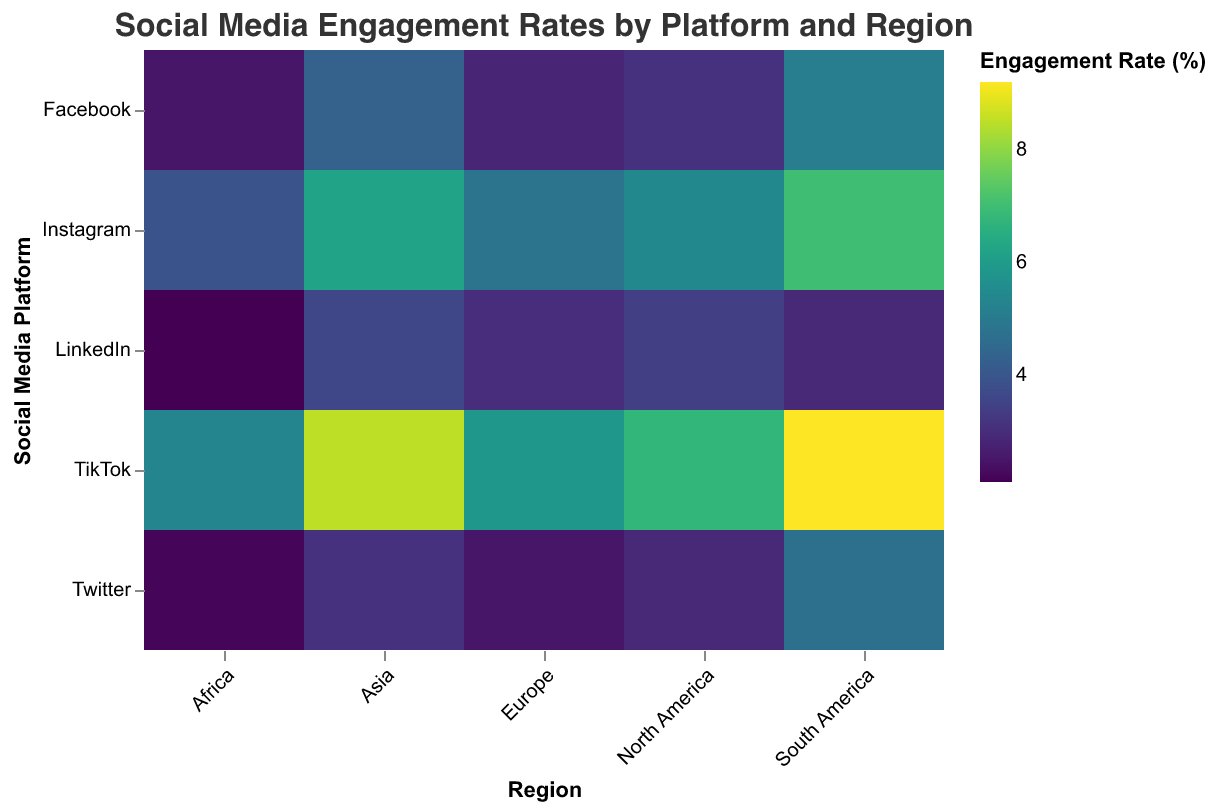What does the title of the heatmap say? The title of the heatmap is located at the top of the figure and provides a summary of what the data represents. The title reads, "Social Media Engagement Rates by Platform and Region," indicating that the heatmap visualizes engagement rates for different social media platforms across various geographical regions.
Answer: Social Media Engagement Rates by Platform and Region Which region has the highest engagement rate on Instagram? To determine which region has the highest engagement rate on Instagram, locate the "Instagram" row and identify the cell with the darkest color, representing the highest engagement rate. The region corresponding to this cell is South America.
Answer: South America What is the engagement rate for Facebook in Europe? To find the engagement rate for Facebook in Europe, locate the "Facebook" row and the "Europe" column. The intersection of this row and column provides the engagement rate value, which is 2.8%.
Answer: 2.8% Compare the engagement rates on TikTok between North America and Asia. Which region has the higher rate, and by how much? To compare the engagement rates on TikTok between North America and Asia, locate the "TikTok" row and identify the values in the "North America" and "Asia" columns. North America's engagement rate is 6.8%, and Asia's is 8.5%. Subtract the smaller value from the larger one (8.5% - 6.8%). Asia has the higher engagement rate by 1.7%.
Answer: Asia by 1.7% What is the average engagement rate for LinkedIn across all regions? To find the average engagement rate for LinkedIn across all regions, first locate the "LinkedIn" row and note the engagement rates for all regions: 3.4%, 3.0%, 3.6%, 2.9%, and 2.1%. Convert these percentages to decimal form and sum them: 0.034 + 0.030 + 0.036 + 0.029 + 0.021 = 0.150. Divide by the number of regions (5): 0.150 / 5 = 0.030. Convert back to percentage form, which is 3.0%.
Answer: 3.0% Which social media platform has the lowest engagement rate in Africa? To identify the social media platform with the lowest engagement rate in Africa, locate the "Africa" column and find the cell with the lightest color, which represents the lowest rate. The corresponding platform is Twitter, with an engagement rate of 2.2%.
Answer: Twitter How does the engagement rate for Twitter in South America compare to that in North America? To compare the engagement rates for Twitter in South America and North America, locate the "Twitter" row and identify the values in the "South America" and "North America" columns. South America's engagement rate is 4.7%, and North America's is 2.9%. South America's rate is higher than North America's.
Answer: South America is higher What is the engagement rate range for Instagram across all regions? To determine the range of engagement rates for Instagram across all regions, locate the "Instagram" row and identify the highest and lowest values: 7.0% in South America and 3.9% in Africa. Subtract the smallest value from the largest (7.0% - 3.9%) to find the range, which is 3.1%.
Answer: 3.1% Which social media platform has the most consistent engagement rates across all regions? To find the social media platform with the most consistent engagement rates, look for the platform with values that are closest to each other across regions. By examining the heatmap, LinkedIn has engagement rates of 3.4%, 3.0%, 3.6%, 2.9%, and 2.1%. Although there is some variation, the differences are smaller compared to other platforms, indicating consistent engagement.
Answer: LinkedIn 